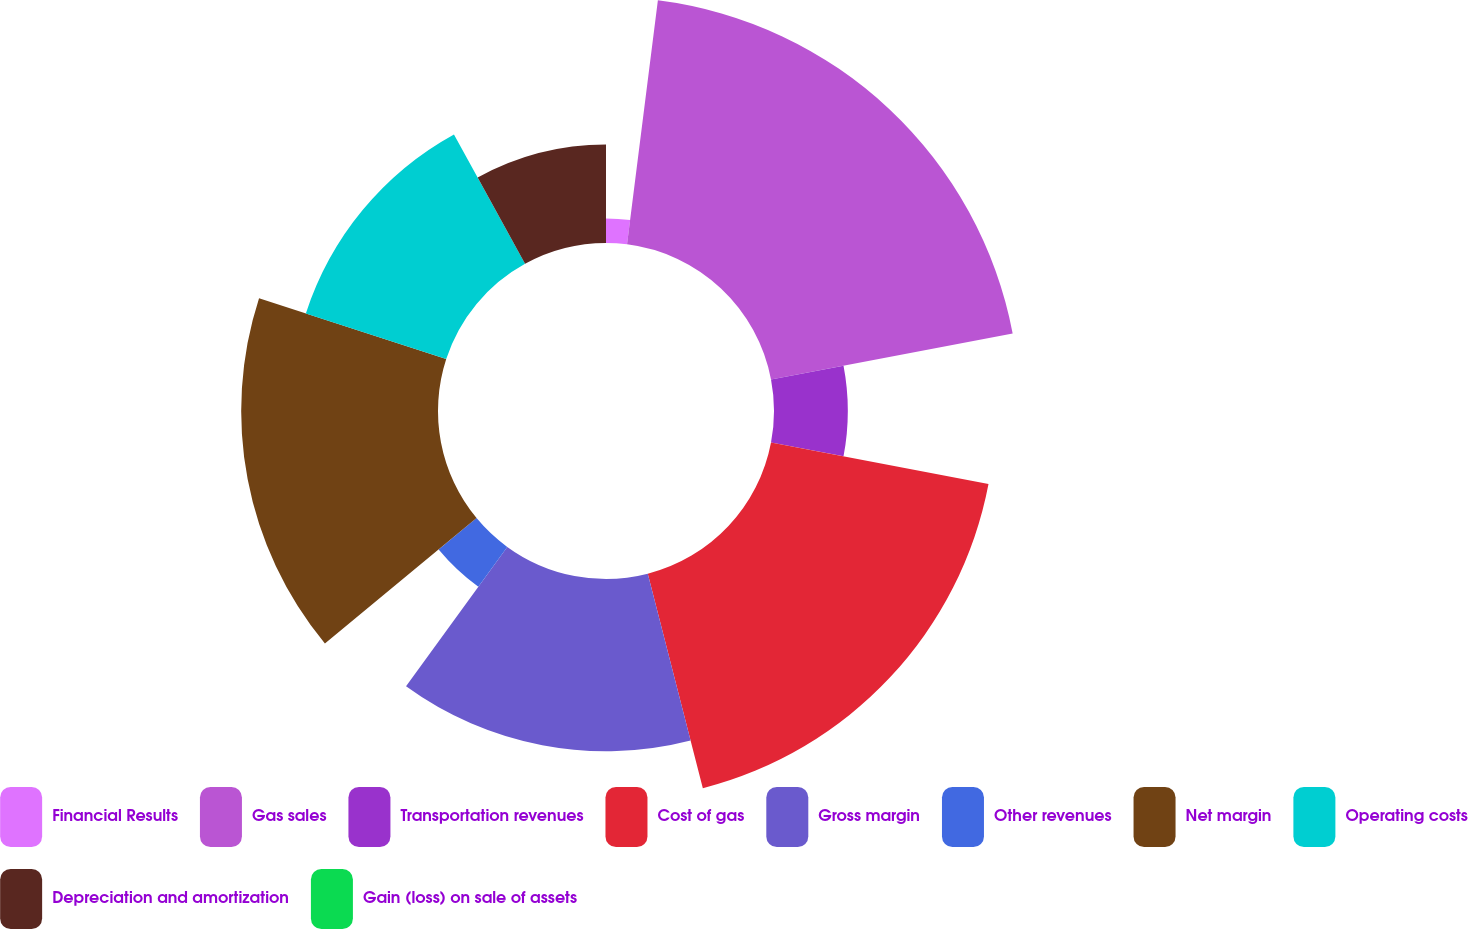Convert chart to OTSL. <chart><loc_0><loc_0><loc_500><loc_500><pie_chart><fcel>Financial Results<fcel>Gas sales<fcel>Transportation revenues<fcel>Cost of gas<fcel>Gross margin<fcel>Other revenues<fcel>Net margin<fcel>Operating costs<fcel>Depreciation and amortization<fcel>Gain (loss) on sale of assets<nl><fcel>2.0%<fcel>20.0%<fcel>6.0%<fcel>18.0%<fcel>14.0%<fcel>4.0%<fcel>16.0%<fcel>12.0%<fcel>8.0%<fcel>0.0%<nl></chart> 